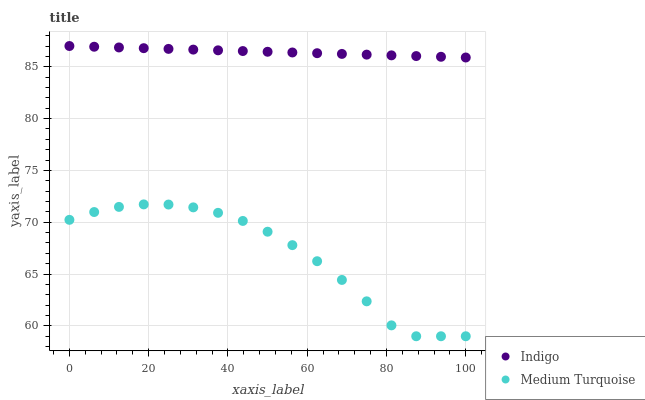Does Medium Turquoise have the minimum area under the curve?
Answer yes or no. Yes. Does Indigo have the maximum area under the curve?
Answer yes or no. Yes. Does Medium Turquoise have the maximum area under the curve?
Answer yes or no. No. Is Indigo the smoothest?
Answer yes or no. Yes. Is Medium Turquoise the roughest?
Answer yes or no. Yes. Is Medium Turquoise the smoothest?
Answer yes or no. No. Does Medium Turquoise have the lowest value?
Answer yes or no. Yes. Does Indigo have the highest value?
Answer yes or no. Yes. Does Medium Turquoise have the highest value?
Answer yes or no. No. Is Medium Turquoise less than Indigo?
Answer yes or no. Yes. Is Indigo greater than Medium Turquoise?
Answer yes or no. Yes. Does Medium Turquoise intersect Indigo?
Answer yes or no. No. 